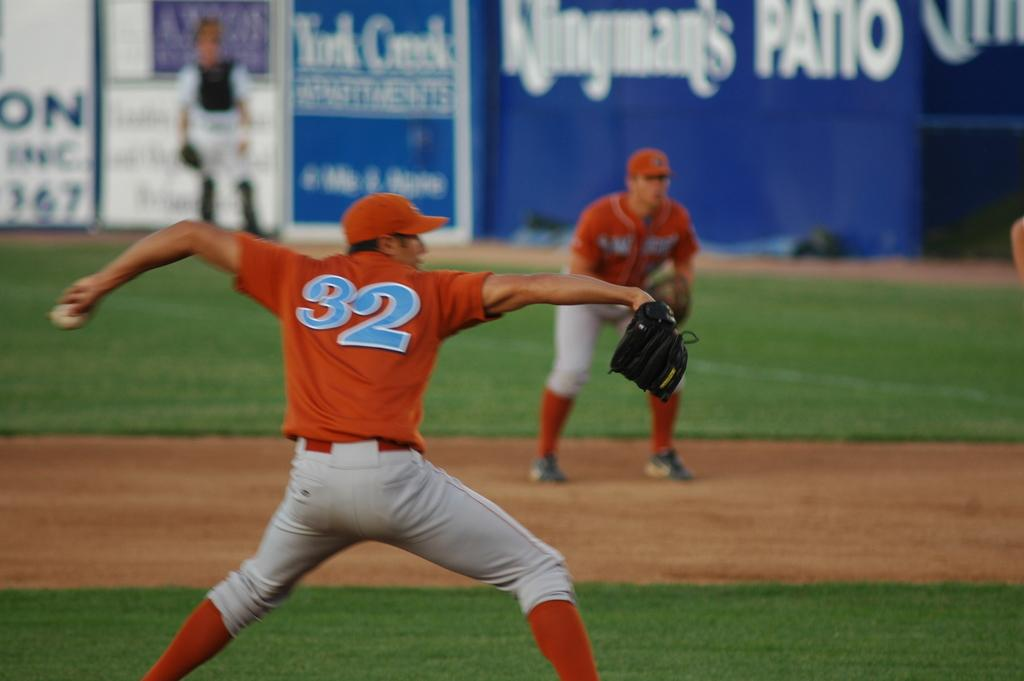<image>
Render a clear and concise summary of the photo. Baseball player #32 in an orage uniform throws the ball. 